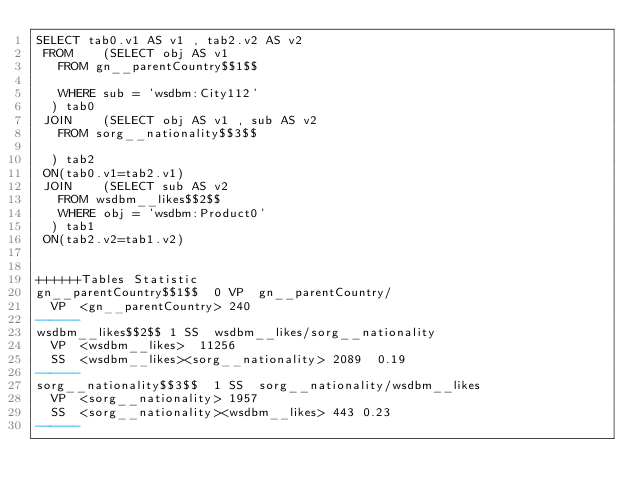Convert code to text. <code><loc_0><loc_0><loc_500><loc_500><_SQL_>SELECT tab0.v1 AS v1 , tab2.v2 AS v2 
 FROM    (SELECT obj AS v1 
	 FROM gn__parentCountry$$1$$
	 
	 WHERE sub = 'wsdbm:City112'
	) tab0
 JOIN    (SELECT obj AS v1 , sub AS v2 
	 FROM sorg__nationality$$3$$
	
	) tab2
 ON(tab0.v1=tab2.v1)
 JOIN    (SELECT sub AS v2 
	 FROM wsdbm__likes$$2$$ 
	 WHERE obj = 'wsdbm:Product0'
	) tab1
 ON(tab2.v2=tab1.v2)


++++++Tables Statistic
gn__parentCountry$$1$$	0	VP	gn__parentCountry/
	VP	<gn__parentCountry>	240
------
wsdbm__likes$$2$$	1	SS	wsdbm__likes/sorg__nationality
	VP	<wsdbm__likes>	11256
	SS	<wsdbm__likes><sorg__nationality>	2089	0.19
------
sorg__nationality$$3$$	1	SS	sorg__nationality/wsdbm__likes
	VP	<sorg__nationality>	1957
	SS	<sorg__nationality><wsdbm__likes>	443	0.23
------
</code> 